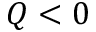Convert formula to latex. <formula><loc_0><loc_0><loc_500><loc_500>Q < 0</formula> 